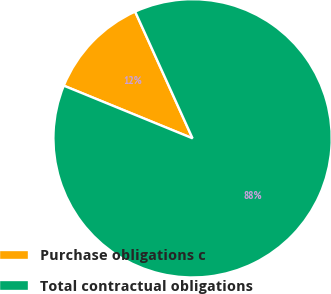Convert chart. <chart><loc_0><loc_0><loc_500><loc_500><pie_chart><fcel>Purchase obligations c<fcel>Total contractual obligations<nl><fcel>12.05%<fcel>87.95%<nl></chart> 